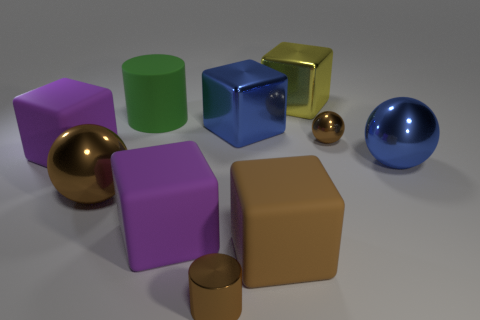What is the shape of the small brown thing behind the purple matte cube in front of the brown object on the left side of the tiny metal cylinder?
Give a very brief answer. Sphere. Is the number of matte objects that are to the right of the big blue cube less than the number of spheres that are behind the brown matte object?
Offer a terse response. Yes. What shape is the tiny thing on the left side of the shiny thing behind the large green object?
Your answer should be very brief. Cylinder. Are there any other things of the same color as the tiny metal cylinder?
Ensure brevity in your answer.  Yes. Is the small metallic ball the same color as the metallic cylinder?
Your answer should be compact. Yes. How many red objects are either big cubes or large metallic cubes?
Offer a very short reply. 0. Are there fewer large green rubber things that are in front of the large green cylinder than big blue cubes?
Your answer should be compact. Yes. There is a brown metallic thing in front of the big brown sphere; how many metallic balls are right of it?
Give a very brief answer. 2. What number of other things are there of the same size as the brown metal cylinder?
Your answer should be compact. 1. What number of objects are either tiny green shiny balls or small brown things that are in front of the big brown rubber thing?
Ensure brevity in your answer.  1. 